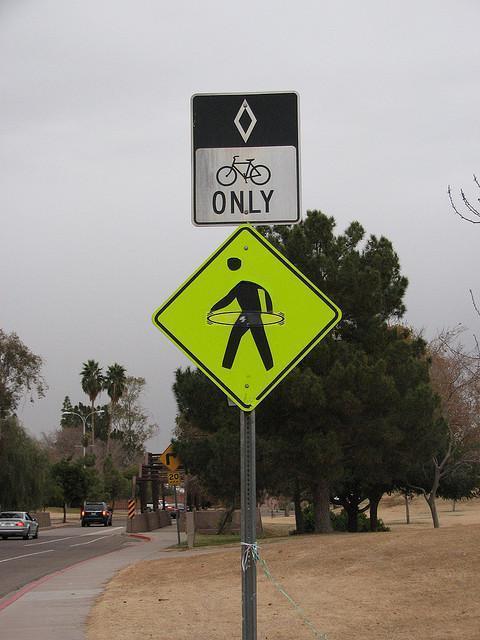How many cars are in the picture?
Give a very brief answer. 2. How many frisbees are there?
Give a very brief answer. 0. 